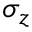<formula> <loc_0><loc_0><loc_500><loc_500>\sigma _ { z }</formula> 